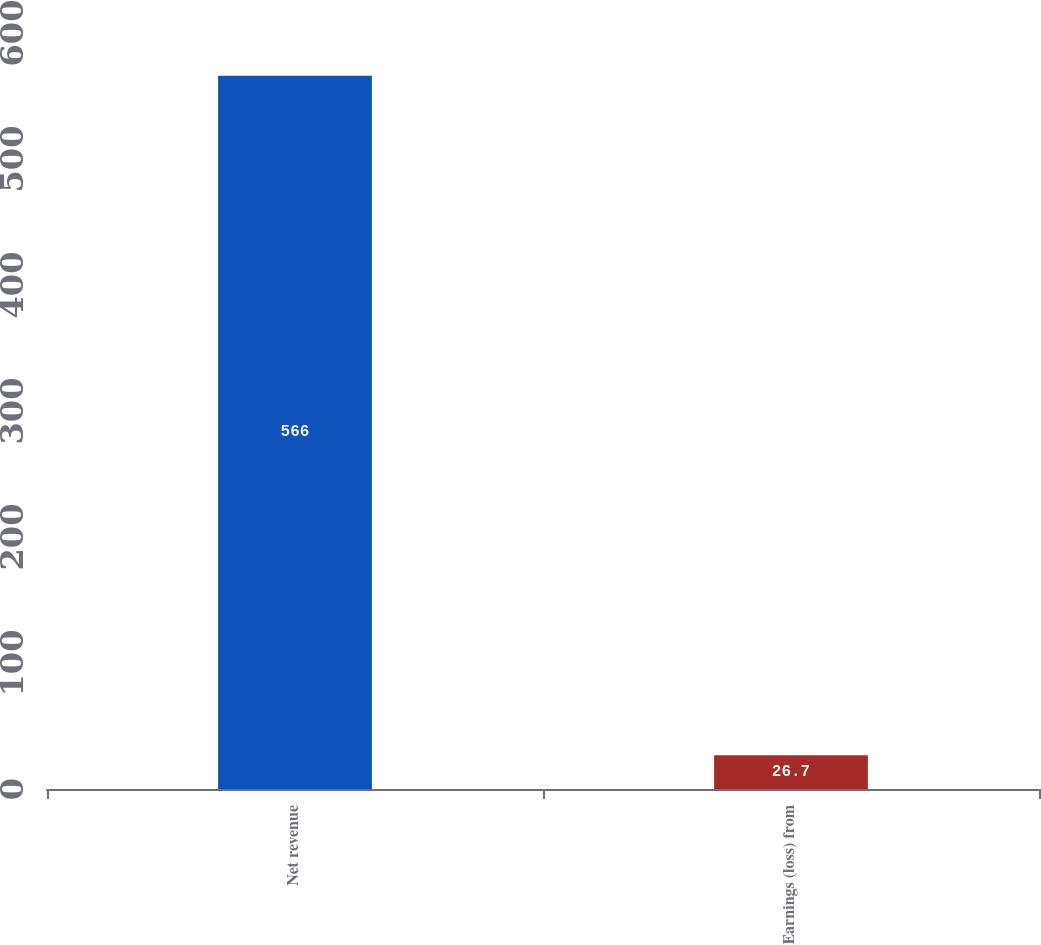Convert chart. <chart><loc_0><loc_0><loc_500><loc_500><bar_chart><fcel>Net revenue<fcel>Earnings (loss) from<nl><fcel>566<fcel>26.7<nl></chart> 